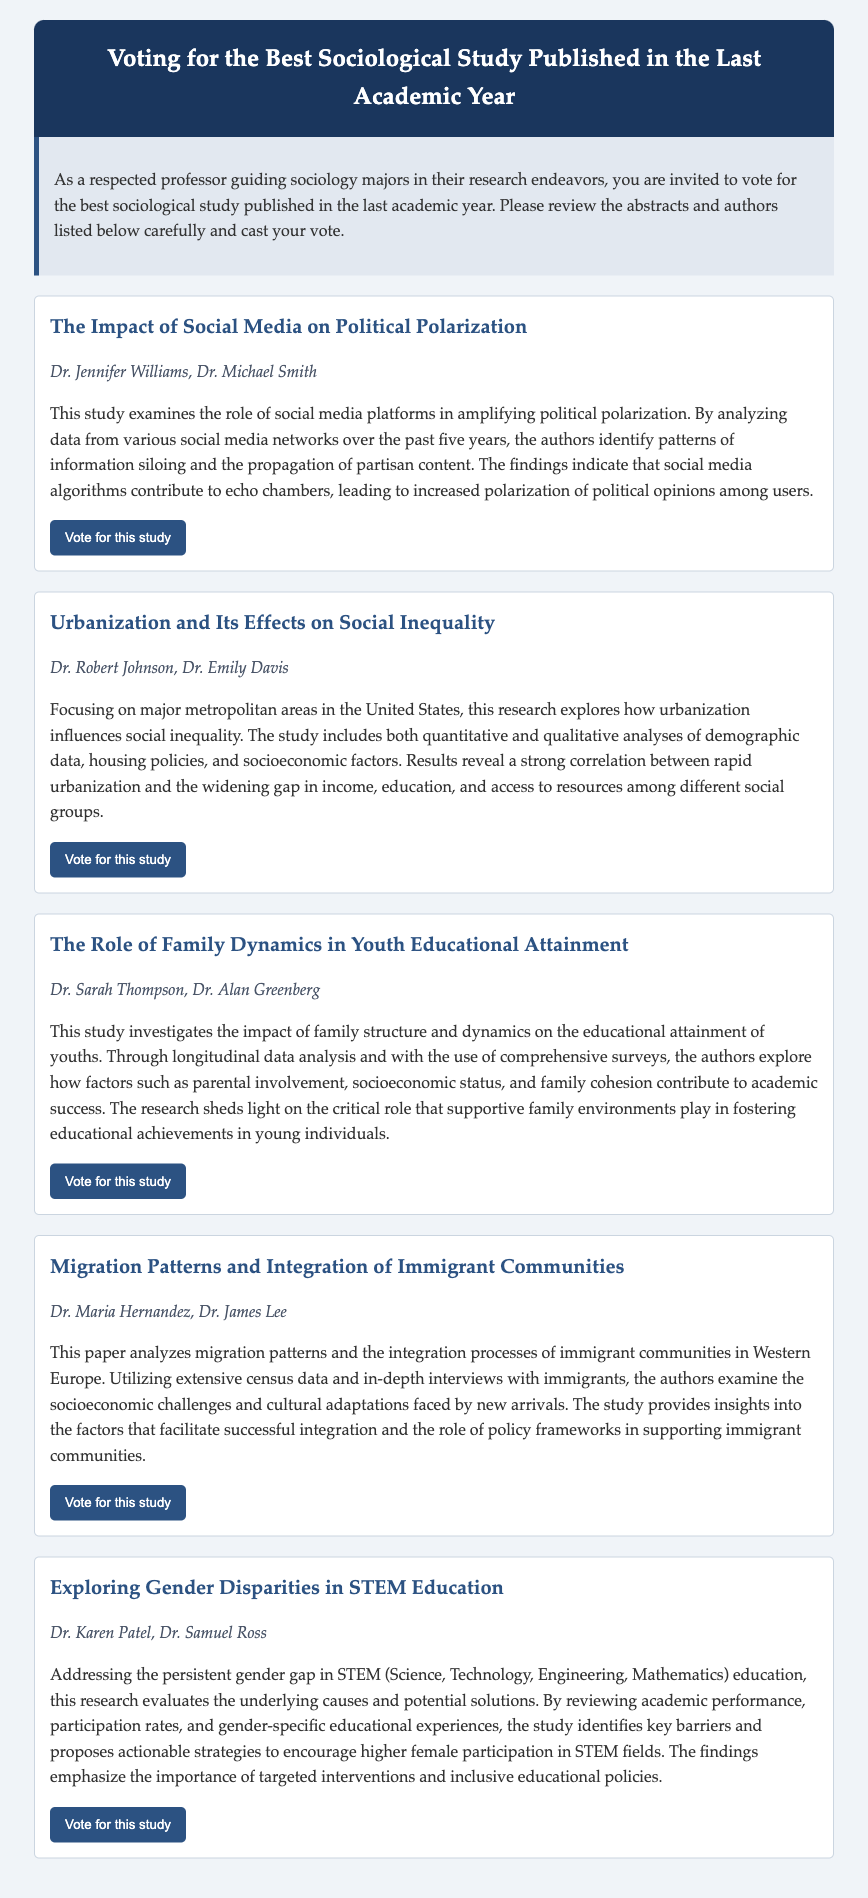What is the title of the first study? The title of the first study is presented in the document as the heading of the first study section.
Answer: The Impact of Social Media on Political Polarization Who are the authors of the study on social inequality? The authors of the study on urbanization and social inequality are listed right below the title in that study's section.
Answer: Dr. Robert Johnson, Dr. Emily Davis What is the main focus of the research conducted by Dr. Sarah Thompson and Dr. Alan Greenberg? The main focus is specified in the abstract of their study, elaborating on family dynamics and youth educational attainment.
Answer: Family dynamics in youth educational attainment How many studies are listed in the ballot? The total number of studies is given by counting the individual sections present in the document.
Answer: Five Which study addresses the topic of gender disparities? This information can be derived from the title of the study focusing on gender disparities in education.
Answer: Exploring Gender Disparities in STEM Education What is the study examining migration patterns about? The abstract provides insights into the content of the study regarding migration patterns and integration.
Answer: Migration patterns and integration of immigrant communities What academic fields does the study on gender disparities in education target? The fields are denoted in the title and can be inferred directly.
Answer: STEM (Science, Technology, Engineering, Mathematics) 